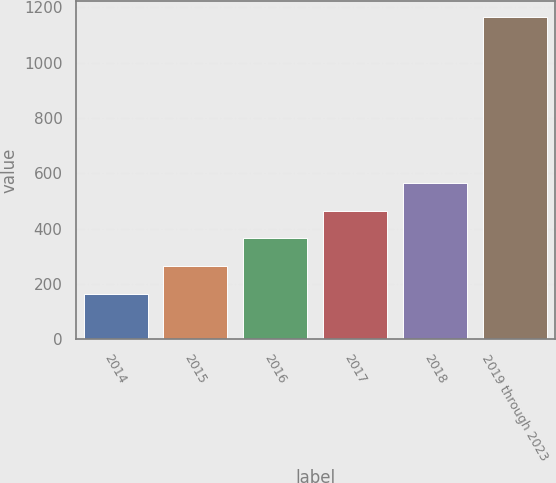Convert chart. <chart><loc_0><loc_0><loc_500><loc_500><bar_chart><fcel>2014<fcel>2015<fcel>2016<fcel>2017<fcel>2018<fcel>2019 through 2023<nl><fcel>165<fcel>265<fcel>365<fcel>465<fcel>565<fcel>1165<nl></chart> 